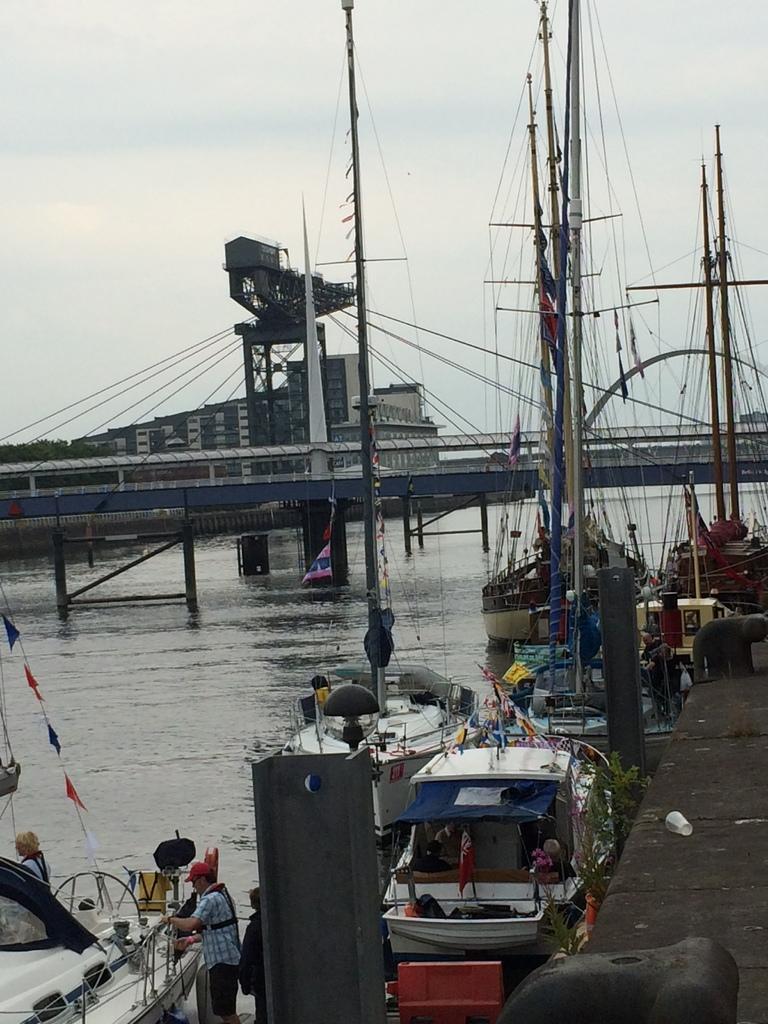Please provide a concise description of this image. In this image there is the sky, there is a building, there are trees truncated towards the left of the image, there is a bridge truncated, there are poles truncated towards the top of the image, there are boats in the sea, there is a person standing, there is a person on the boat, there are objects truncated towards the bottom of the image, there are objects truncated towards the right of the image. 